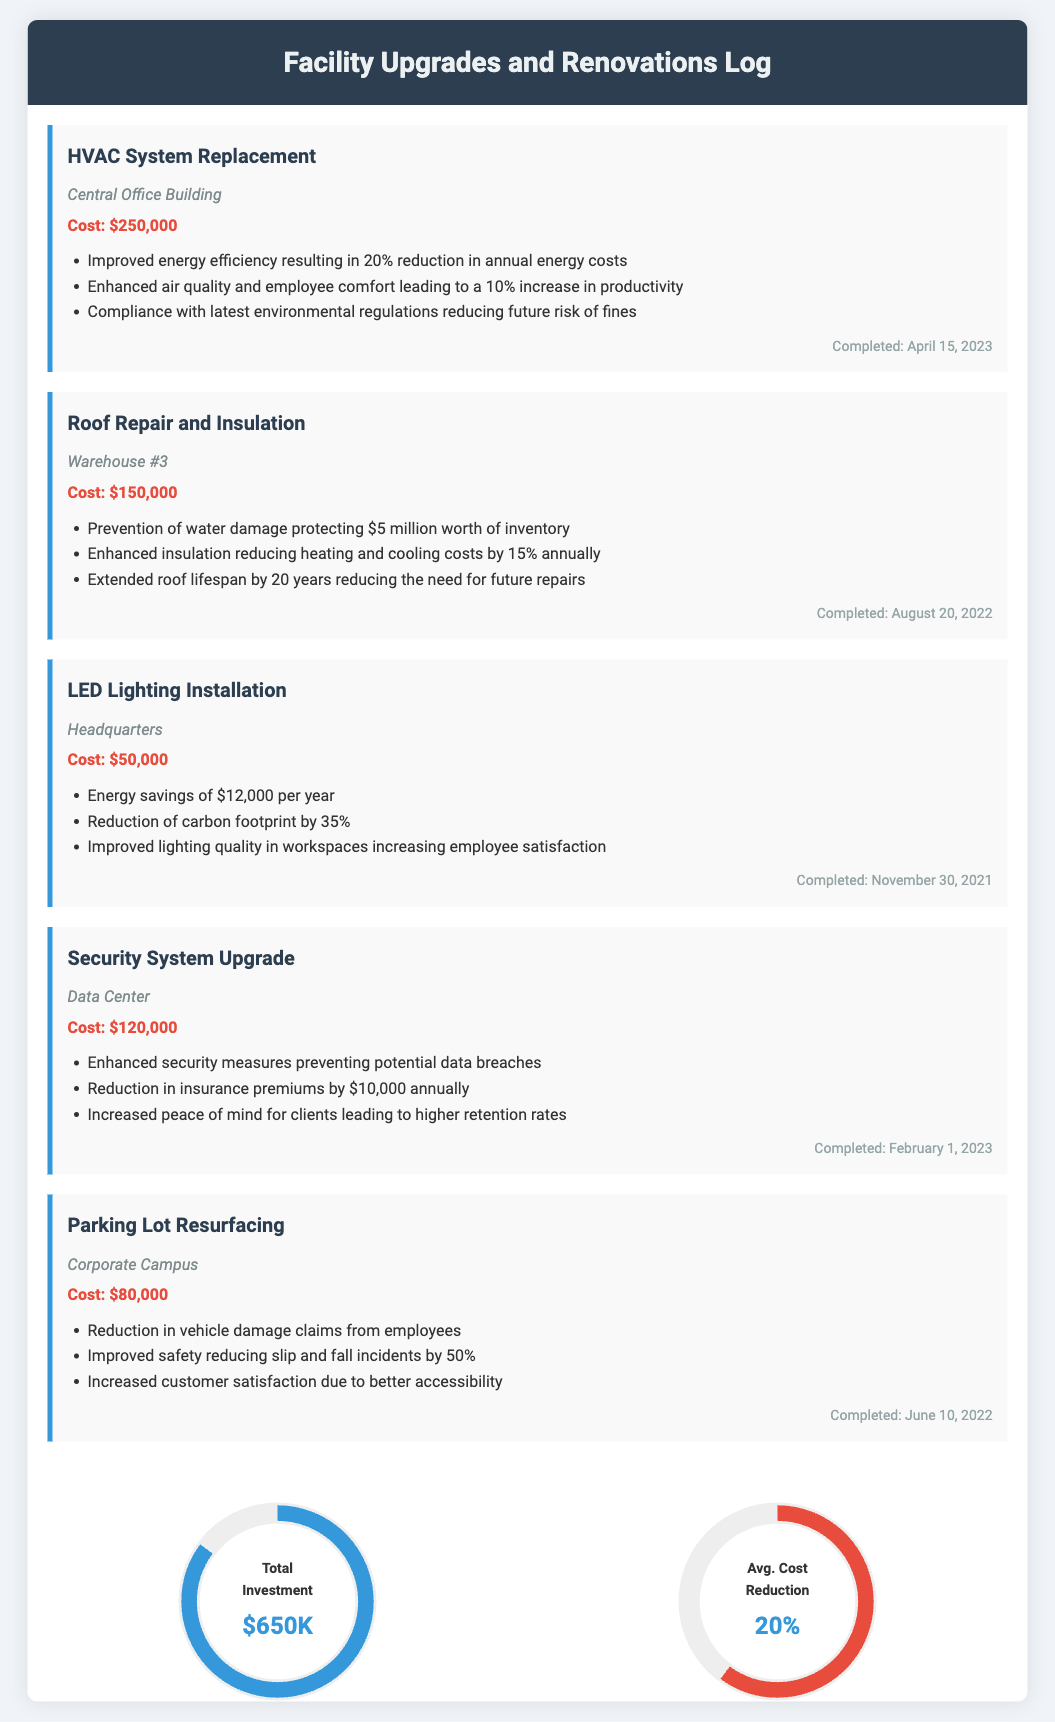What is the total investment in facility upgrades? The total investment is listed at the end of the document, which sums up to $650,000.
Answer: $650K What was the cost of the LED Lighting Installation? The cost for the LED Lighting Installation is stated in the log as $50,000.
Answer: $50,000 Which facility had the HVAC System Replacement? The document specifies that the HVAC System Replacement was done at the Central Office Building.
Answer: Central Office Building When was the Roof Repair and Insulation completed? The completion date for the Roof Repair and Insulation is mentioned as August 20, 2022.
Answer: August 20, 2022 What percentage reduction in annual energy costs is expected from the HVAC System Replacement? The anticipated reduction in annual energy costs is stated as 20%.
Answer: 20% How much does the security system upgrade reduce insurance premiums annually? The document notes that the Security System Upgrade results in a reduction of $10,000 in insurance premiums annually.
Answer: $10,000 What is the benefit of improved insulation from the Roof Repair and Insulation? The improved insulation leads to reduced heating and cooling costs by 15% annually.
Answer: 15% What was the completion date for the Security System Upgrade? The document indicates that the Security System Upgrade was completed on February 1, 2023.
Answer: February 1, 2023 Which upgrade type is expected to increase employee satisfaction due to improved lighting quality? The upgrade type mentioned for better lighting quality and increased employee satisfaction is the LED Lighting Installation.
Answer: LED Lighting Installation 